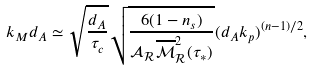Convert formula to latex. <formula><loc_0><loc_0><loc_500><loc_500>k _ { M } d _ { A } \simeq \sqrt { \frac { d _ { A } } { \tau _ { c } } } \sqrt { \frac { 6 ( 1 - n _ { s } ) } { { \mathcal { A } } _ { \mathcal { R } } \overline { \mathcal { M } } _ { \mathcal { R } } ^ { 2 } ( \tau _ { * } ) } } ( d _ { A } k _ { p } ) ^ { ( n - 1 ) / 2 } ,</formula> 